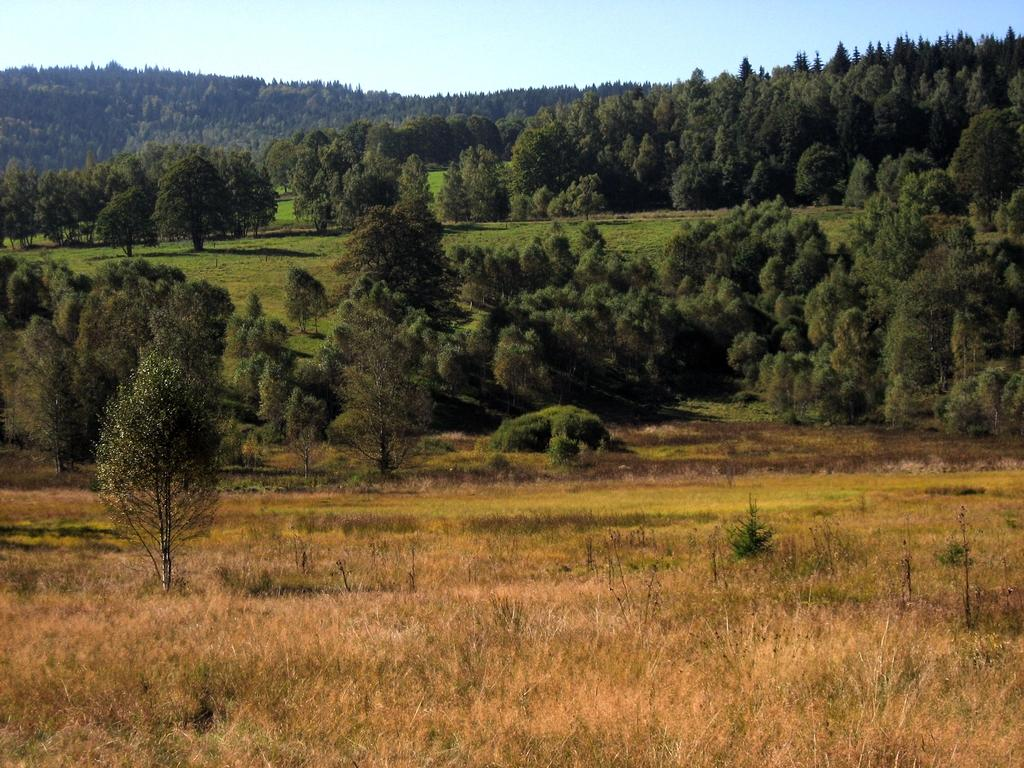What type of terrain is visible in the image? The ground is visible in the image, and there are hills present. What type of vegetation can be seen in the image? There is grass, plants, and trees visible in the image. What part of the natural environment is visible in the image? The sky is visible in the image. What time does the clock show in the image? There is no clock present in the image. What type of bat is flying in the image? There are no bats present in the image. 